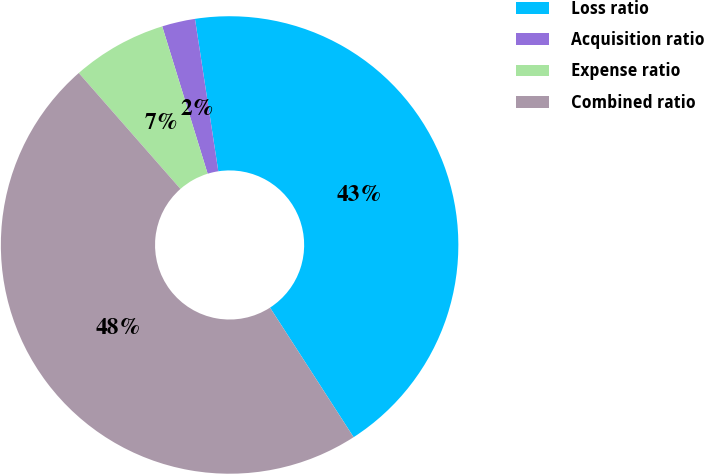Convert chart to OTSL. <chart><loc_0><loc_0><loc_500><loc_500><pie_chart><fcel>Loss ratio<fcel>Acquisition ratio<fcel>Expense ratio<fcel>Combined ratio<nl><fcel>43.3%<fcel>2.34%<fcel>6.7%<fcel>47.66%<nl></chart> 